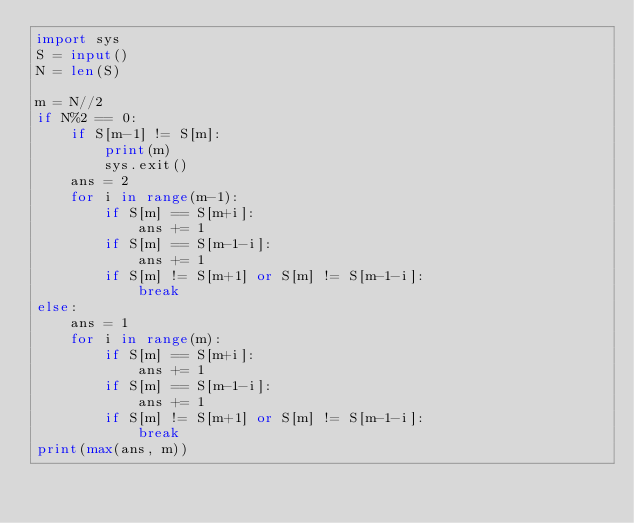Convert code to text. <code><loc_0><loc_0><loc_500><loc_500><_Python_>import sys
S = input()
N = len(S)

m = N//2
if N%2 == 0:
    if S[m-1] != S[m]:
        print(m)
        sys.exit()
    ans = 2
    for i in range(m-1):
        if S[m] == S[m+i]:
            ans += 1
        if S[m] == S[m-1-i]:
            ans += 1
        if S[m] != S[m+1] or S[m] != S[m-1-i]:
            break
else:
    ans = 1
    for i in range(m):
        if S[m] == S[m+i]:
            ans += 1
        if S[m] == S[m-1-i]:
            ans += 1
        if S[m] != S[m+1] or S[m] != S[m-1-i]:
            break
print(max(ans, m))
</code> 